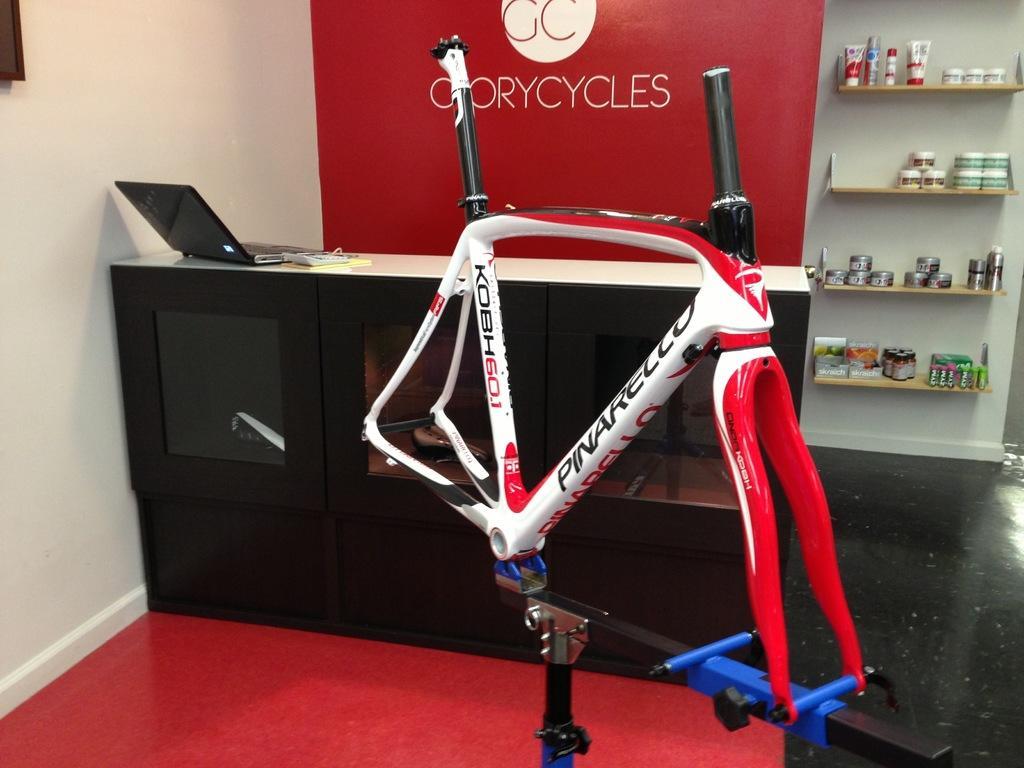How would you summarize this image in a sentence or two? In this image there is a hoarding, red wall, floor, racks, cupboard, rods and objects. On the table there is a laptop and an object. In that racks there are objects. Something is written on the red wall. 